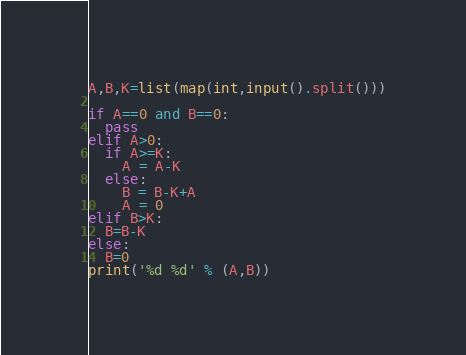<code> <loc_0><loc_0><loc_500><loc_500><_Python_>A,B,K=list(map(int,input().split()))

if A==0 and B==0:
  pass
elif A>0:
  if A>=K:
  	A = A-K
  else:
    B = B-K+A
    A = 0
elif B>K:
  B=B-K
else:
  B=0
print('%d %d' % (A,B))</code> 